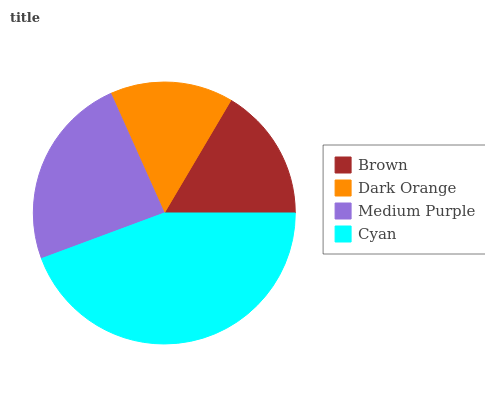Is Dark Orange the minimum?
Answer yes or no. Yes. Is Cyan the maximum?
Answer yes or no. Yes. Is Medium Purple the minimum?
Answer yes or no. No. Is Medium Purple the maximum?
Answer yes or no. No. Is Medium Purple greater than Dark Orange?
Answer yes or no. Yes. Is Dark Orange less than Medium Purple?
Answer yes or no. Yes. Is Dark Orange greater than Medium Purple?
Answer yes or no. No. Is Medium Purple less than Dark Orange?
Answer yes or no. No. Is Medium Purple the high median?
Answer yes or no. Yes. Is Brown the low median?
Answer yes or no. Yes. Is Brown the high median?
Answer yes or no. No. Is Cyan the low median?
Answer yes or no. No. 